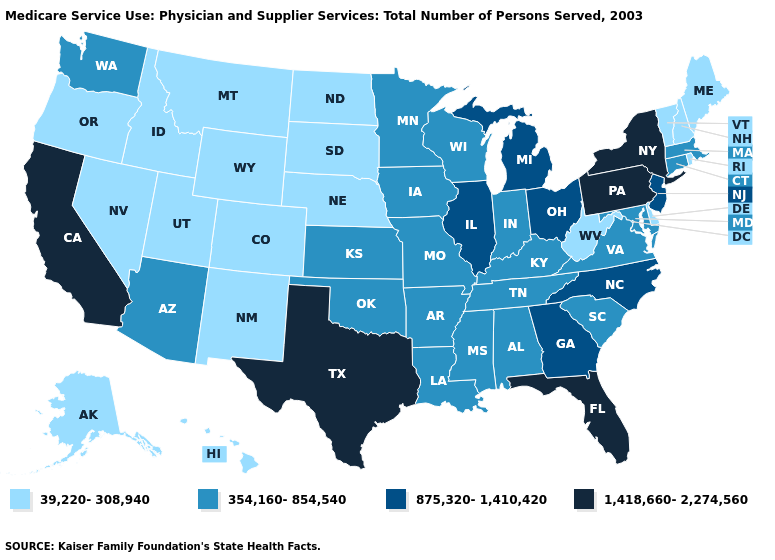What is the value of Maine?
Answer briefly. 39,220-308,940. Which states hav the highest value in the Northeast?
Answer briefly. New York, Pennsylvania. Name the states that have a value in the range 1,418,660-2,274,560?
Quick response, please. California, Florida, New York, Pennsylvania, Texas. Which states have the highest value in the USA?
Write a very short answer. California, Florida, New York, Pennsylvania, Texas. Which states hav the highest value in the MidWest?
Short answer required. Illinois, Michigan, Ohio. Name the states that have a value in the range 39,220-308,940?
Concise answer only. Alaska, Colorado, Delaware, Hawaii, Idaho, Maine, Montana, Nebraska, Nevada, New Hampshire, New Mexico, North Dakota, Oregon, Rhode Island, South Dakota, Utah, Vermont, West Virginia, Wyoming. Name the states that have a value in the range 875,320-1,410,420?
Give a very brief answer. Georgia, Illinois, Michigan, New Jersey, North Carolina, Ohio. Name the states that have a value in the range 39,220-308,940?
Concise answer only. Alaska, Colorado, Delaware, Hawaii, Idaho, Maine, Montana, Nebraska, Nevada, New Hampshire, New Mexico, North Dakota, Oregon, Rhode Island, South Dakota, Utah, Vermont, West Virginia, Wyoming. What is the value of New Jersey?
Short answer required. 875,320-1,410,420. What is the lowest value in the Northeast?
Answer briefly. 39,220-308,940. Which states have the lowest value in the USA?
Be succinct. Alaska, Colorado, Delaware, Hawaii, Idaho, Maine, Montana, Nebraska, Nevada, New Hampshire, New Mexico, North Dakota, Oregon, Rhode Island, South Dakota, Utah, Vermont, West Virginia, Wyoming. Among the states that border Delaware , which have the lowest value?
Give a very brief answer. Maryland. Does Texas have the same value as Minnesota?
Short answer required. No. Name the states that have a value in the range 1,418,660-2,274,560?
Quick response, please. California, Florida, New York, Pennsylvania, Texas. What is the value of Alaska?
Concise answer only. 39,220-308,940. 